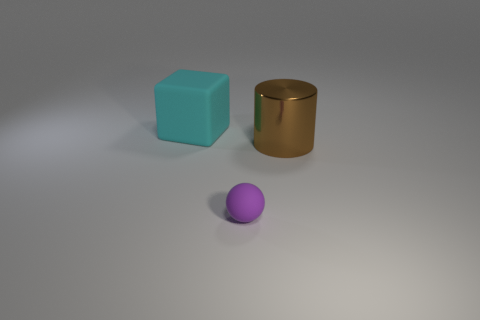Are there any other things that have the same material as the brown object?
Make the answer very short. No. There is another cyan thing that is the same size as the shiny thing; what material is it?
Provide a succinct answer. Rubber. How many objects are large things to the left of the small purple matte object or blue balls?
Offer a terse response. 1. Are there the same number of big cylinders that are in front of the small purple object and brown matte cubes?
Your answer should be compact. Yes. The object that is behind the small purple object and to the right of the big block is what color?
Offer a terse response. Brown. What number of cubes are either big metallic things or small rubber objects?
Keep it short and to the point. 0. Are there fewer brown objects that are in front of the big matte block than big blue rubber cylinders?
Ensure brevity in your answer.  No. The thing that is made of the same material as the sphere is what shape?
Offer a very short reply. Cube. What number of large matte cubes are the same color as the small matte object?
Provide a short and direct response. 0. What number of objects are spheres or big cylinders?
Your answer should be compact. 2. 